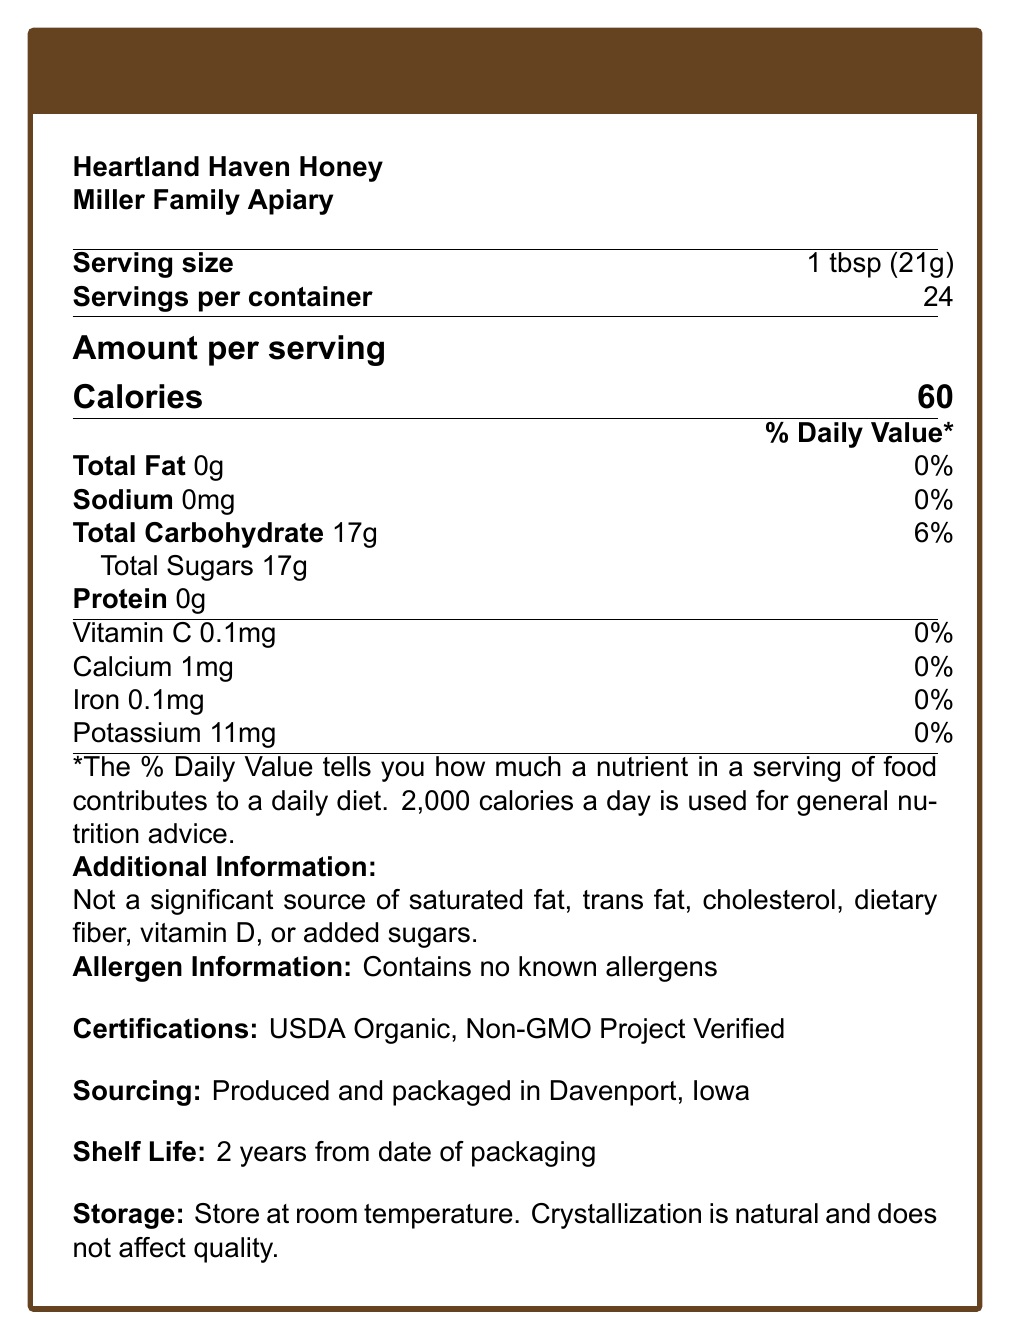what is the serving size? The serving size is clearly stated in the document under "Serving size".
Answer: 1 tbsp (21g) how many servings are there per container? The document mentions this information right below the serving size as "Servings per container".
Answer: 24 how many calories are there per serving? The calories per serving are prominently displayed under "Amount per serving".
Answer: 60 What is the percentage of daily value for total carbohydrates? The document lists this under "Total Carbohydrate" in the nutrition details.
Answer: 6% What is the amount of total sugar per serving? This is stated under "Total Carbohydrate" with a specific mention for total sugars.
Answer: 17g where is the honey produced and packaged? The sourcing information section specifies "Produced and packaged in Davenport, Iowa".
Answer: Davenport, Iowa What certifications does Heartland Haven Honey have? The certifications are listed towards the bottom of the document under a separate section titled "Certifications".
Answer: USDA Organic and Non-GMO Project Verified What is the shelf life of the honey? A. 1 year B. 2 years C. 3 years D. 4 years The document indicates a 2-year shelf life from the date of packaging.
Answer: B. 2 years which nutrients have a daily value percentage of 0%? A. Total Fat, Sodium, Vitamin C, Calcium, Iron, Potassium B. Total Fat, Sodium, Vitamin C, Protein, Iron C. Vitamin C, Calcium, Iron, Potassium D. Total Fat, Sodium, Protein, Vitamin C The document shows each of these nutrients with a 0% daily value.
Answer: A. Total Fat, Sodium, Vitamin C, Calcium, Iron, Potassium is this honey a significant source of dietary fiber or vitamin D? The document explicitly states that it's not a significant source of dietary fiber or vitamin D.
Answer: No summarize the main information in this document. The summary encompasses all major sections - nutrition facts, additional information, and storage/sourcing details.
Answer: The document provides the nutrition facts for Heartland Haven Honey produced by Miller Family Apiary. It details the serving size, servings per container, and nutritional content per serving, including calories, fats, sodium, carbs, sugars, and some vitamins and minerals. Additional information includes allergen info, certifications, sourcing, shelf life, and storage instructions. what are the storage instructions for this honey? The storage instructions are listed at the end of the document in clear terms.
Answer: Store at room temperature. Crystallization is natural and does not affect quality. does the honey contain any known allergens? The allergen information clearly states "Contains no known allergens".
Answer: No what is the amount of cholesterol in a serving? The document states it is not a significant source of cholesterol but does not provide specific amounts.
Answer: Not enough information what is the main source of calories in this honey? Given the listed nutritional facts, the 17g of total sugars is the likely main source of the 60 calories per serving.
Answer: Total Sugars 